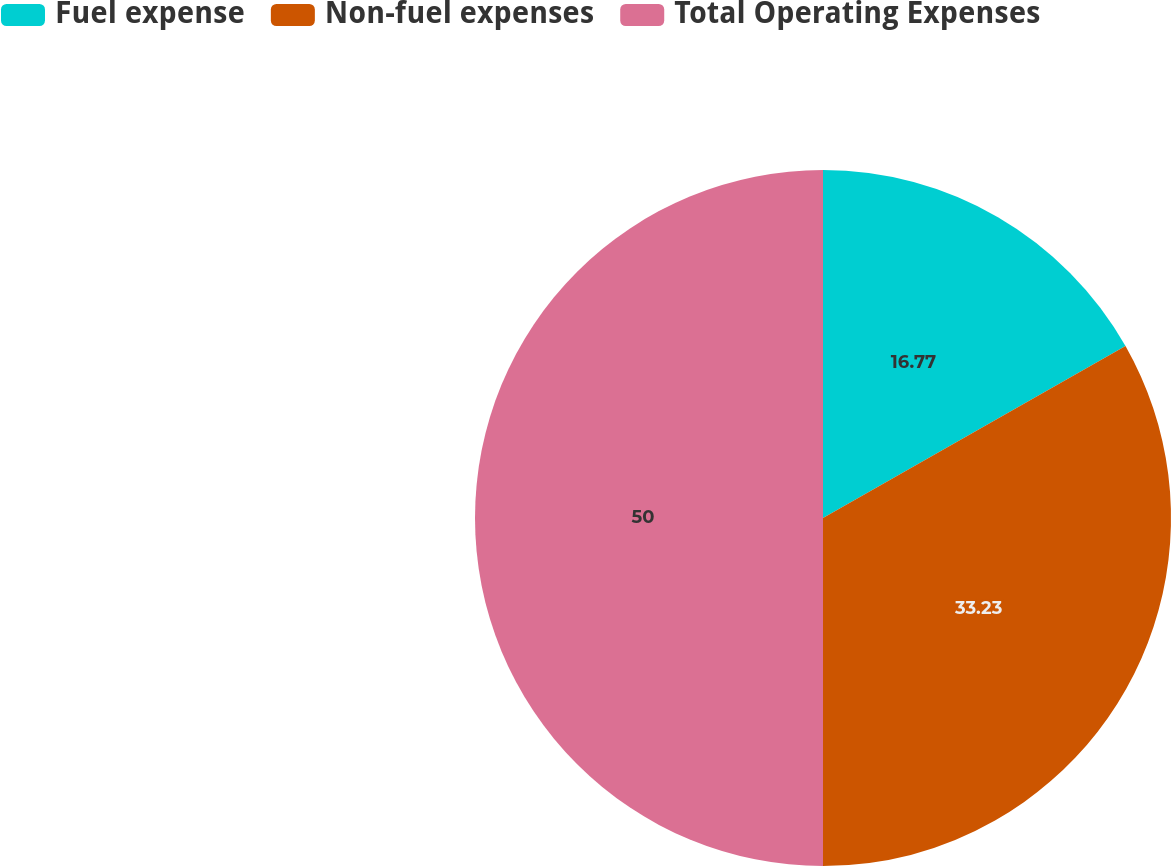<chart> <loc_0><loc_0><loc_500><loc_500><pie_chart><fcel>Fuel expense<fcel>Non-fuel expenses<fcel>Total Operating Expenses<nl><fcel>16.77%<fcel>33.23%<fcel>50.0%<nl></chart> 